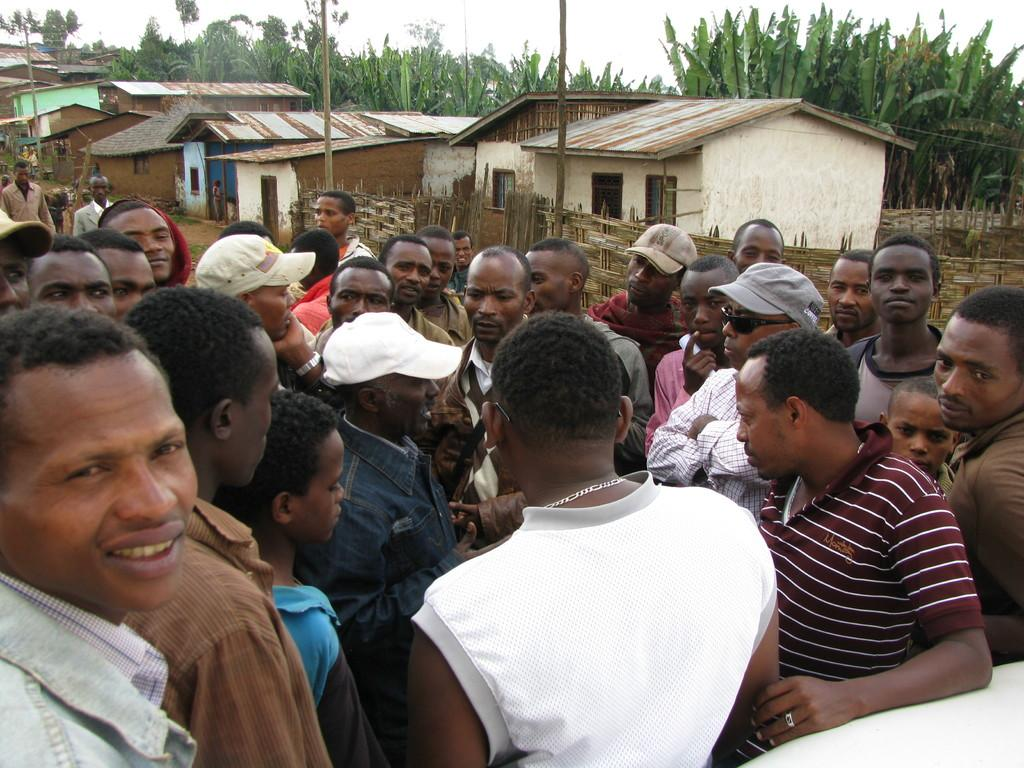What is happening in the image? There is a group of people standing in the image. What can be seen in the background of the image? There are houses, electric poles, and trees with green color in the background of the image. What is the color of the sky in the image? The sky is in white color in the image. What month is it in the image? The month cannot be determined from the image, as there is no information about the time of year. Can you see any friends in the image? The term "friends" is not mentioned in the facts provided, so it cannot be determined if any friends are present in the image. 